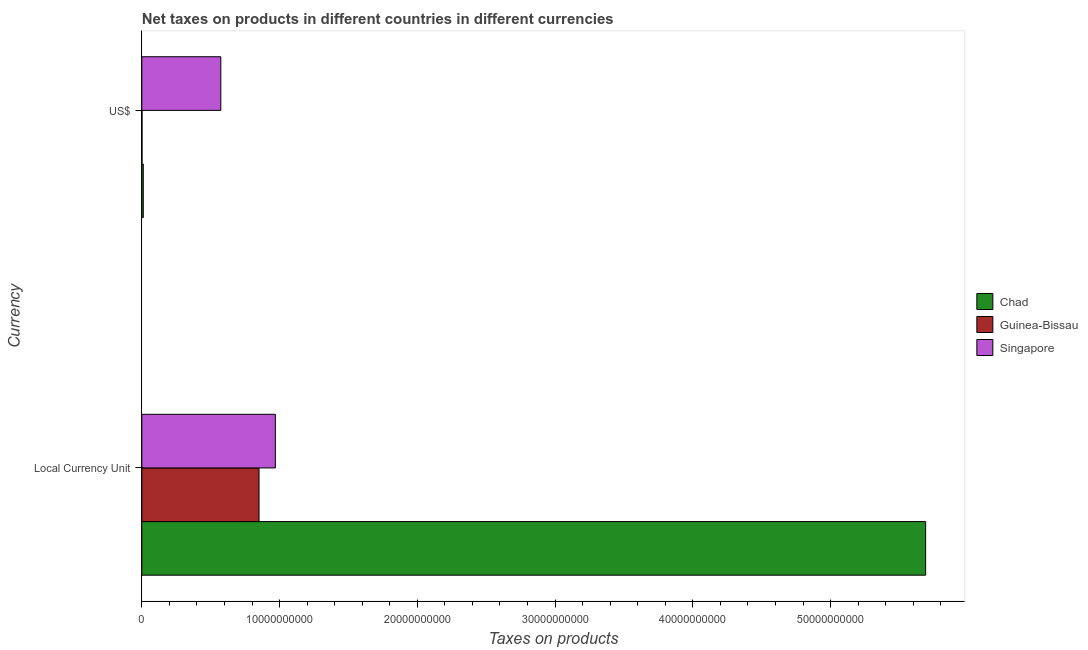How many different coloured bars are there?
Ensure brevity in your answer.  3. How many groups of bars are there?
Offer a terse response. 2. Are the number of bars on each tick of the Y-axis equal?
Give a very brief answer. Yes. How many bars are there on the 2nd tick from the bottom?
Provide a short and direct response. 3. What is the label of the 2nd group of bars from the top?
Provide a short and direct response. Local Currency Unit. What is the net taxes in constant 2005 us$ in Singapore?
Offer a very short reply. 9.69e+09. Across all countries, what is the maximum net taxes in constant 2005 us$?
Offer a terse response. 5.69e+1. Across all countries, what is the minimum net taxes in constant 2005 us$?
Your answer should be very brief. 8.51e+09. In which country was the net taxes in constant 2005 us$ maximum?
Make the answer very short. Chad. In which country was the net taxes in us$ minimum?
Offer a terse response. Guinea-Bissau. What is the total net taxes in constant 2005 us$ in the graph?
Your answer should be compact. 7.51e+1. What is the difference between the net taxes in constant 2005 us$ in Chad and that in Singapore?
Your answer should be very brief. 4.72e+1. What is the difference between the net taxes in constant 2005 us$ in Singapore and the net taxes in us$ in Chad?
Offer a terse response. 9.59e+09. What is the average net taxes in us$ per country?
Give a very brief answer. 1.95e+09. What is the difference between the net taxes in constant 2005 us$ and net taxes in us$ in Singapore?
Provide a succinct answer. 3.96e+09. What is the ratio of the net taxes in us$ in Chad to that in Singapore?
Provide a short and direct response. 0.02. Is the net taxes in constant 2005 us$ in Guinea-Bissau less than that in Chad?
Offer a terse response. Yes. In how many countries, is the net taxes in constant 2005 us$ greater than the average net taxes in constant 2005 us$ taken over all countries?
Your answer should be compact. 1. What does the 3rd bar from the top in Local Currency Unit represents?
Keep it short and to the point. Chad. What does the 2nd bar from the bottom in Local Currency Unit represents?
Offer a very short reply. Guinea-Bissau. How many bars are there?
Your response must be concise. 6. Are all the bars in the graph horizontal?
Your response must be concise. Yes. How many countries are there in the graph?
Offer a very short reply. 3. What is the difference between two consecutive major ticks on the X-axis?
Give a very brief answer. 1.00e+1. Are the values on the major ticks of X-axis written in scientific E-notation?
Offer a terse response. No. Does the graph contain grids?
Ensure brevity in your answer.  No. Where does the legend appear in the graph?
Offer a very short reply. Center right. How are the legend labels stacked?
Provide a succinct answer. Vertical. What is the title of the graph?
Ensure brevity in your answer.  Net taxes on products in different countries in different currencies. Does "Belize" appear as one of the legend labels in the graph?
Give a very brief answer. No. What is the label or title of the X-axis?
Your response must be concise. Taxes on products. What is the label or title of the Y-axis?
Offer a terse response. Currency. What is the Taxes on products of Chad in Local Currency Unit?
Your answer should be very brief. 5.69e+1. What is the Taxes on products in Guinea-Bissau in Local Currency Unit?
Keep it short and to the point. 8.51e+09. What is the Taxes on products of Singapore in Local Currency Unit?
Your response must be concise. 9.69e+09. What is the Taxes on products of Chad in US$?
Make the answer very short. 1.08e+08. What is the Taxes on products in Guinea-Bissau in US$?
Give a very brief answer. 1.61e+07. What is the Taxes on products of Singapore in US$?
Offer a terse response. 5.74e+09. Across all Currency, what is the maximum Taxes on products of Chad?
Offer a terse response. 5.69e+1. Across all Currency, what is the maximum Taxes on products of Guinea-Bissau?
Offer a very short reply. 8.51e+09. Across all Currency, what is the maximum Taxes on products of Singapore?
Provide a succinct answer. 9.69e+09. Across all Currency, what is the minimum Taxes on products of Chad?
Your answer should be very brief. 1.08e+08. Across all Currency, what is the minimum Taxes on products in Guinea-Bissau?
Give a very brief answer. 1.61e+07. Across all Currency, what is the minimum Taxes on products of Singapore?
Provide a succinct answer. 5.74e+09. What is the total Taxes on products in Chad in the graph?
Offer a very short reply. 5.70e+1. What is the total Taxes on products in Guinea-Bissau in the graph?
Provide a short and direct response. 8.53e+09. What is the total Taxes on products in Singapore in the graph?
Your answer should be very brief. 1.54e+1. What is the difference between the Taxes on products in Chad in Local Currency Unit and that in US$?
Give a very brief answer. 5.68e+1. What is the difference between the Taxes on products of Guinea-Bissau in Local Currency Unit and that in US$?
Give a very brief answer. 8.49e+09. What is the difference between the Taxes on products of Singapore in Local Currency Unit and that in US$?
Your answer should be very brief. 3.96e+09. What is the difference between the Taxes on products in Chad in Local Currency Unit and the Taxes on products in Guinea-Bissau in US$?
Your answer should be compact. 5.69e+1. What is the difference between the Taxes on products in Chad in Local Currency Unit and the Taxes on products in Singapore in US$?
Offer a terse response. 5.12e+1. What is the difference between the Taxes on products of Guinea-Bissau in Local Currency Unit and the Taxes on products of Singapore in US$?
Offer a terse response. 2.77e+09. What is the average Taxes on products in Chad per Currency?
Ensure brevity in your answer.  2.85e+1. What is the average Taxes on products in Guinea-Bissau per Currency?
Provide a succinct answer. 4.26e+09. What is the average Taxes on products in Singapore per Currency?
Your answer should be very brief. 7.71e+09. What is the difference between the Taxes on products of Chad and Taxes on products of Guinea-Bissau in Local Currency Unit?
Give a very brief answer. 4.84e+1. What is the difference between the Taxes on products of Chad and Taxes on products of Singapore in Local Currency Unit?
Keep it short and to the point. 4.72e+1. What is the difference between the Taxes on products in Guinea-Bissau and Taxes on products in Singapore in Local Currency Unit?
Your response must be concise. -1.18e+09. What is the difference between the Taxes on products in Chad and Taxes on products in Guinea-Bissau in US$?
Your answer should be very brief. 9.16e+07. What is the difference between the Taxes on products in Chad and Taxes on products in Singapore in US$?
Offer a very short reply. -5.63e+09. What is the difference between the Taxes on products of Guinea-Bissau and Taxes on products of Singapore in US$?
Make the answer very short. -5.72e+09. What is the ratio of the Taxes on products of Chad in Local Currency Unit to that in US$?
Offer a terse response. 528.28. What is the ratio of the Taxes on products in Guinea-Bissau in Local Currency Unit to that in US$?
Your answer should be very brief. 528.28. What is the ratio of the Taxes on products of Singapore in Local Currency Unit to that in US$?
Your response must be concise. 1.69. What is the difference between the highest and the second highest Taxes on products in Chad?
Ensure brevity in your answer.  5.68e+1. What is the difference between the highest and the second highest Taxes on products of Guinea-Bissau?
Your answer should be very brief. 8.49e+09. What is the difference between the highest and the second highest Taxes on products of Singapore?
Give a very brief answer. 3.96e+09. What is the difference between the highest and the lowest Taxes on products of Chad?
Your response must be concise. 5.68e+1. What is the difference between the highest and the lowest Taxes on products in Guinea-Bissau?
Offer a terse response. 8.49e+09. What is the difference between the highest and the lowest Taxes on products of Singapore?
Your response must be concise. 3.96e+09. 